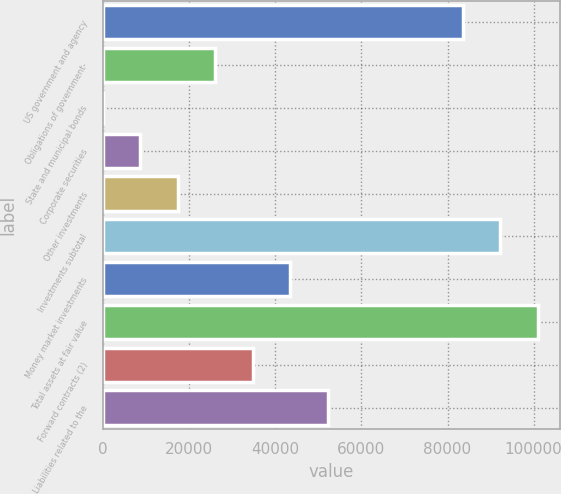Convert chart to OTSL. <chart><loc_0><loc_0><loc_500><loc_500><bar_chart><fcel>US government and agency<fcel>Obligations of government-<fcel>State and municipal bonds<fcel>Corporate securities<fcel>Other investments<fcel>Investments subtotal<fcel>Money market investments<fcel>Total assets at fair value<fcel>Forward contracts (2)<fcel>Liabilities related to the<nl><fcel>83532<fcel>26125.7<fcel>0.32<fcel>8708.79<fcel>17417.3<fcel>92240.5<fcel>43542.7<fcel>100949<fcel>34834.2<fcel>52251.1<nl></chart> 